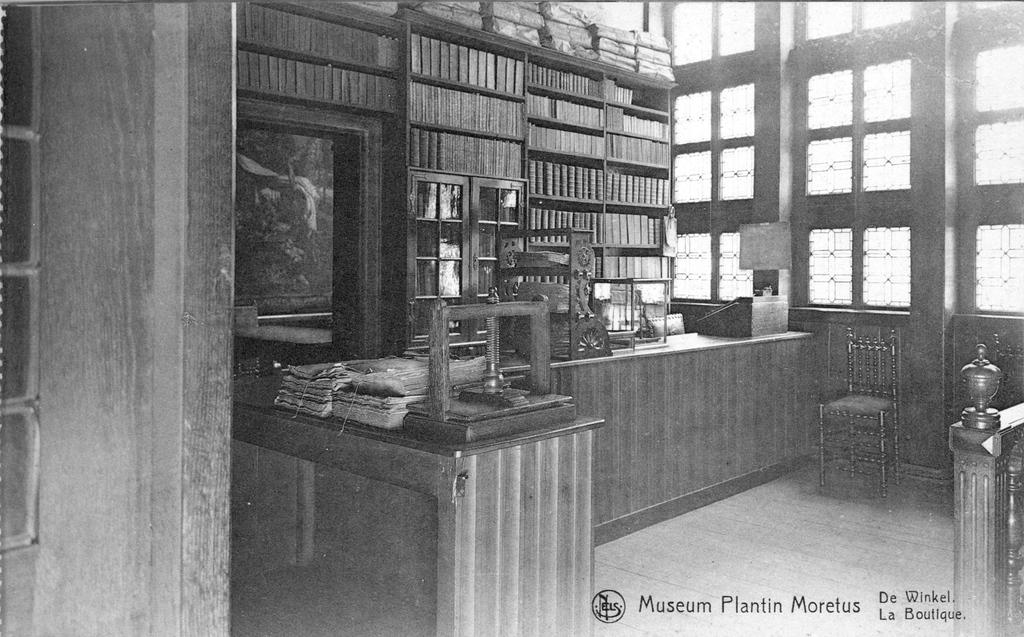Provide a one-sentence caption for the provided image. a black and white photo of the museum plantin morfeus. 